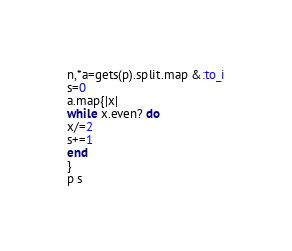Convert code to text. <code><loc_0><loc_0><loc_500><loc_500><_Ruby_>n,*a=gets(p).split.map &:to_i
s=0
a.map{|x|
while x.even? do
x/=2
s+=1
end
}
p s</code> 